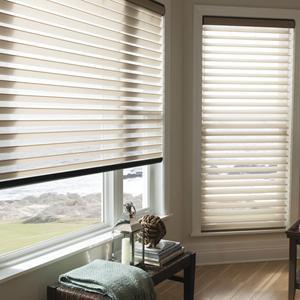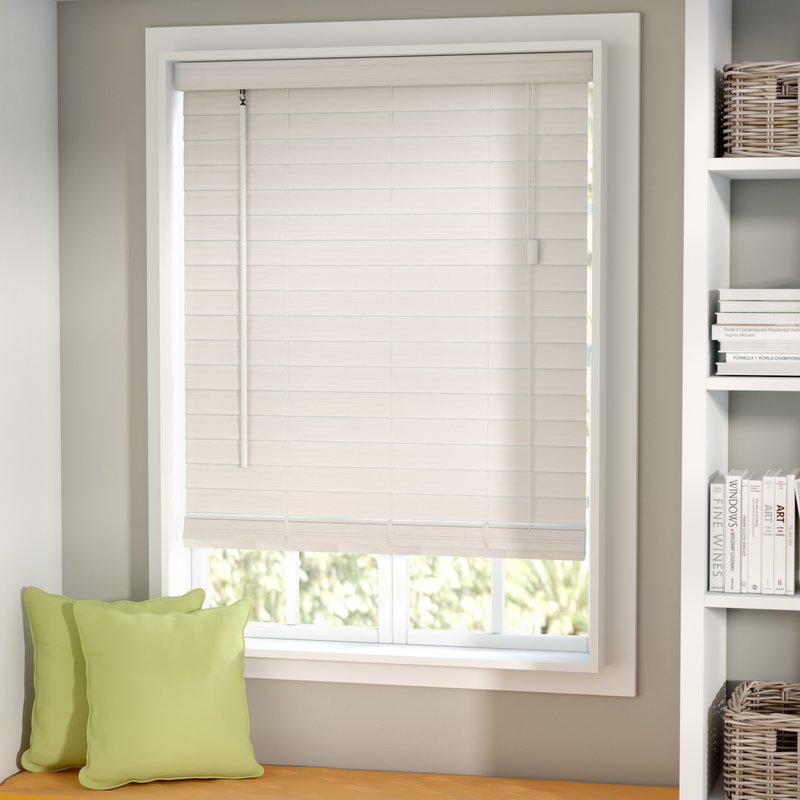The first image is the image on the left, the second image is the image on the right. For the images shown, is this caption "There are exactly two window shades in the right image." true? Answer yes or no. No. The first image is the image on the left, the second image is the image on the right. Examine the images to the left and right. Is the description "There is a total of three blinds." accurate? Answer yes or no. Yes. 